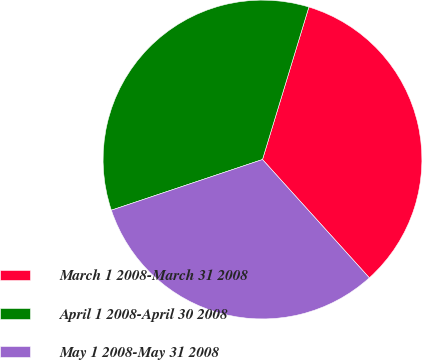Convert chart. <chart><loc_0><loc_0><loc_500><loc_500><pie_chart><fcel>March 1 2008-March 31 2008<fcel>April 1 2008-April 30 2008<fcel>May 1 2008-May 31 2008<nl><fcel>33.61%<fcel>34.85%<fcel>31.54%<nl></chart> 